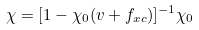<formula> <loc_0><loc_0><loc_500><loc_500>\chi = [ 1 - \chi _ { 0 } ( v + f _ { x c } ) ] ^ { - 1 } \chi _ { 0 }</formula> 